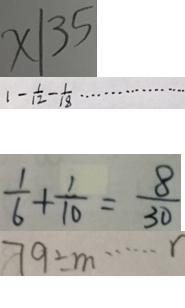Convert formula to latex. <formula><loc_0><loc_0><loc_500><loc_500>x \vert 3 5 
 1 - \frac { 1 } { 1 2 } - \frac { 1 } { 1 8 } \cdots 
 \frac { 1 } { 6 } + \frac { 1 } { 1 0 } = \frac { 8 } { 3 0 } 
 7 9 \div m \cdots r</formula> 